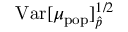<formula> <loc_0><loc_0><loc_500><loc_500>V a r [ \mu _ { p o p } ] _ { \hat { p } } ^ { 1 / 2 }</formula> 